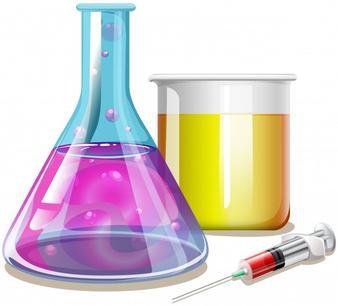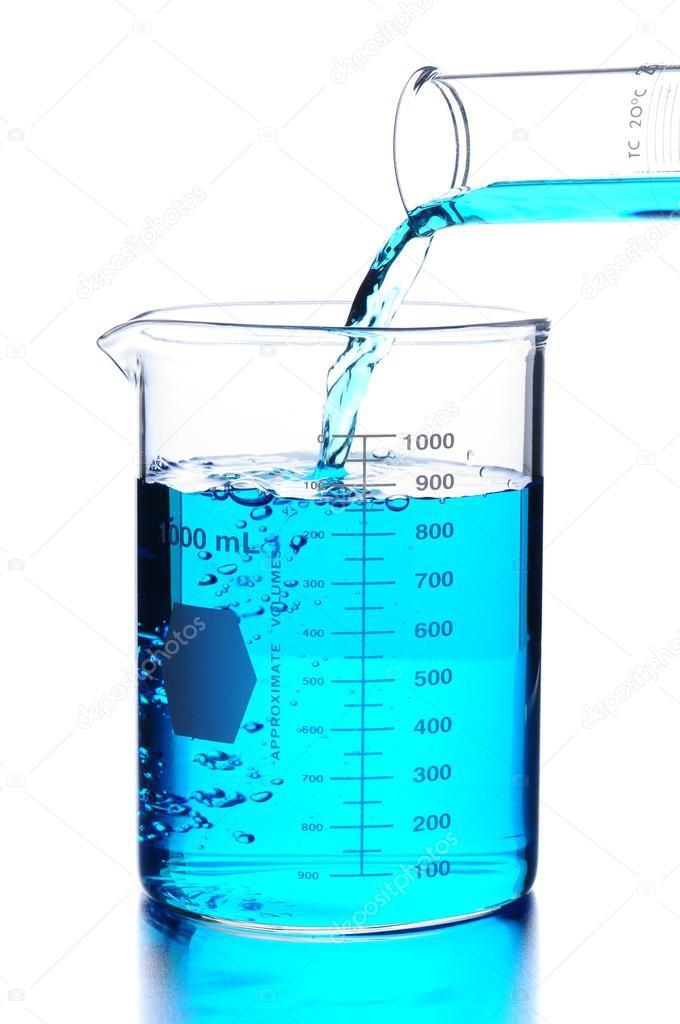The first image is the image on the left, the second image is the image on the right. Assess this claim about the two images: "One image shows exactly five containers of liquid in varying sizes and includes the colors green, yellow, and purple.". Correct or not? Answer yes or no. No. The first image is the image on the left, the second image is the image on the right. Analyze the images presented: Is the assertion "All of the upright beakers of various shapes contain colored liquids." valid? Answer yes or no. Yes. 